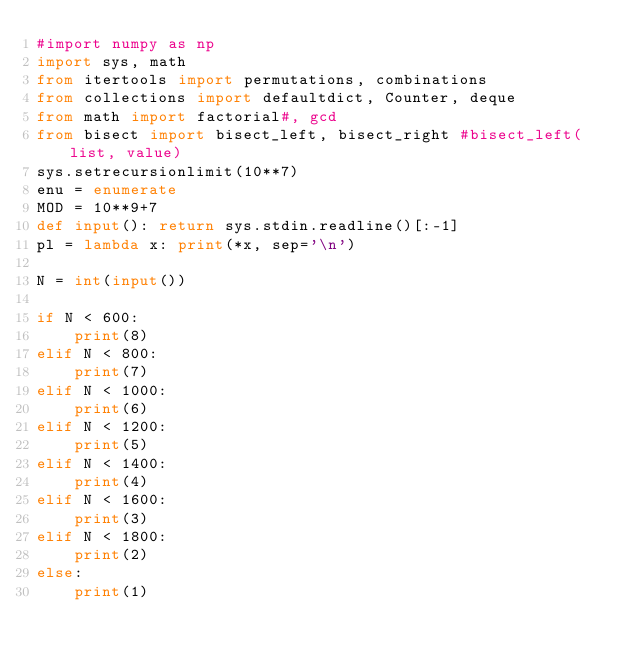Convert code to text. <code><loc_0><loc_0><loc_500><loc_500><_Python_>#import numpy as np
import sys, math
from itertools import permutations, combinations
from collections import defaultdict, Counter, deque
from math import factorial#, gcd
from bisect import bisect_left, bisect_right #bisect_left(list, value)
sys.setrecursionlimit(10**7)
enu = enumerate
MOD = 10**9+7
def input(): return sys.stdin.readline()[:-1]
pl = lambda x: print(*x, sep='\n')

N = int(input())

if N < 600:
    print(8)
elif N < 800:
    print(7)
elif N < 1000:
    print(6)
elif N < 1200:
    print(5)
elif N < 1400:
    print(4)
elif N < 1600:
    print(3)
elif N < 1800:
    print(2)
else:
    print(1)</code> 